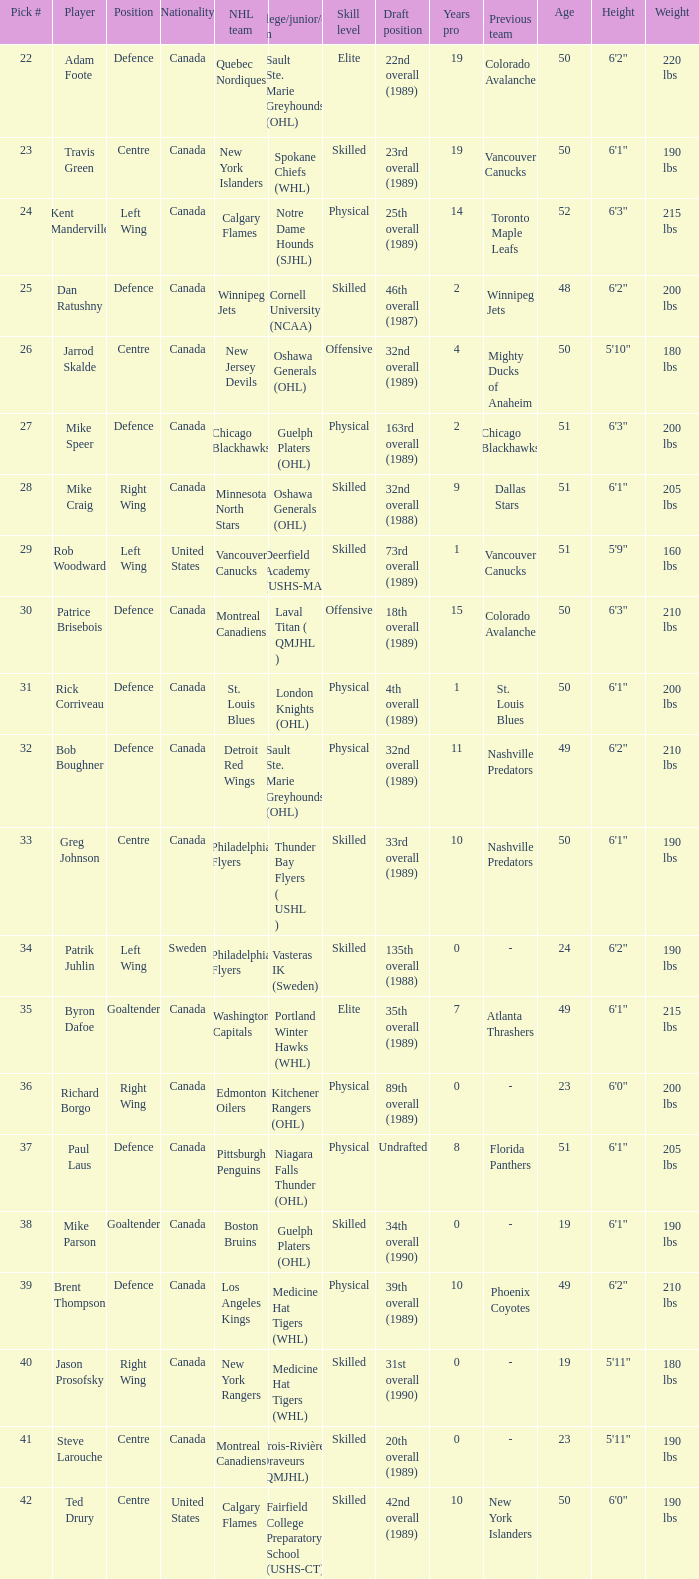What player came from Cornell University (NCAA)? Dan Ratushny. 